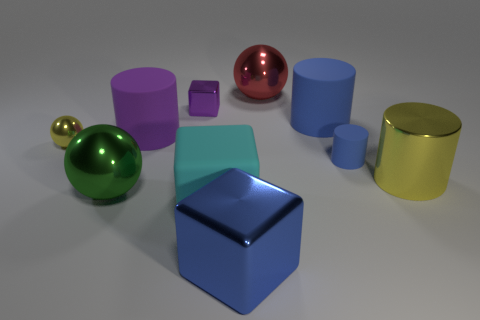Subtract all purple cubes. How many blue cylinders are left? 2 Subtract all purple cylinders. How many cylinders are left? 3 Subtract all yellow cylinders. How many cylinders are left? 3 Subtract 1 cylinders. How many cylinders are left? 3 Subtract all gray cylinders. Subtract all gray spheres. How many cylinders are left? 4 Subtract all balls. How many objects are left? 7 Add 3 blue matte cylinders. How many blue matte cylinders are left? 5 Add 3 cyan rubber things. How many cyan rubber things exist? 4 Subtract 1 yellow spheres. How many objects are left? 9 Subtract all metal cylinders. Subtract all blue things. How many objects are left? 6 